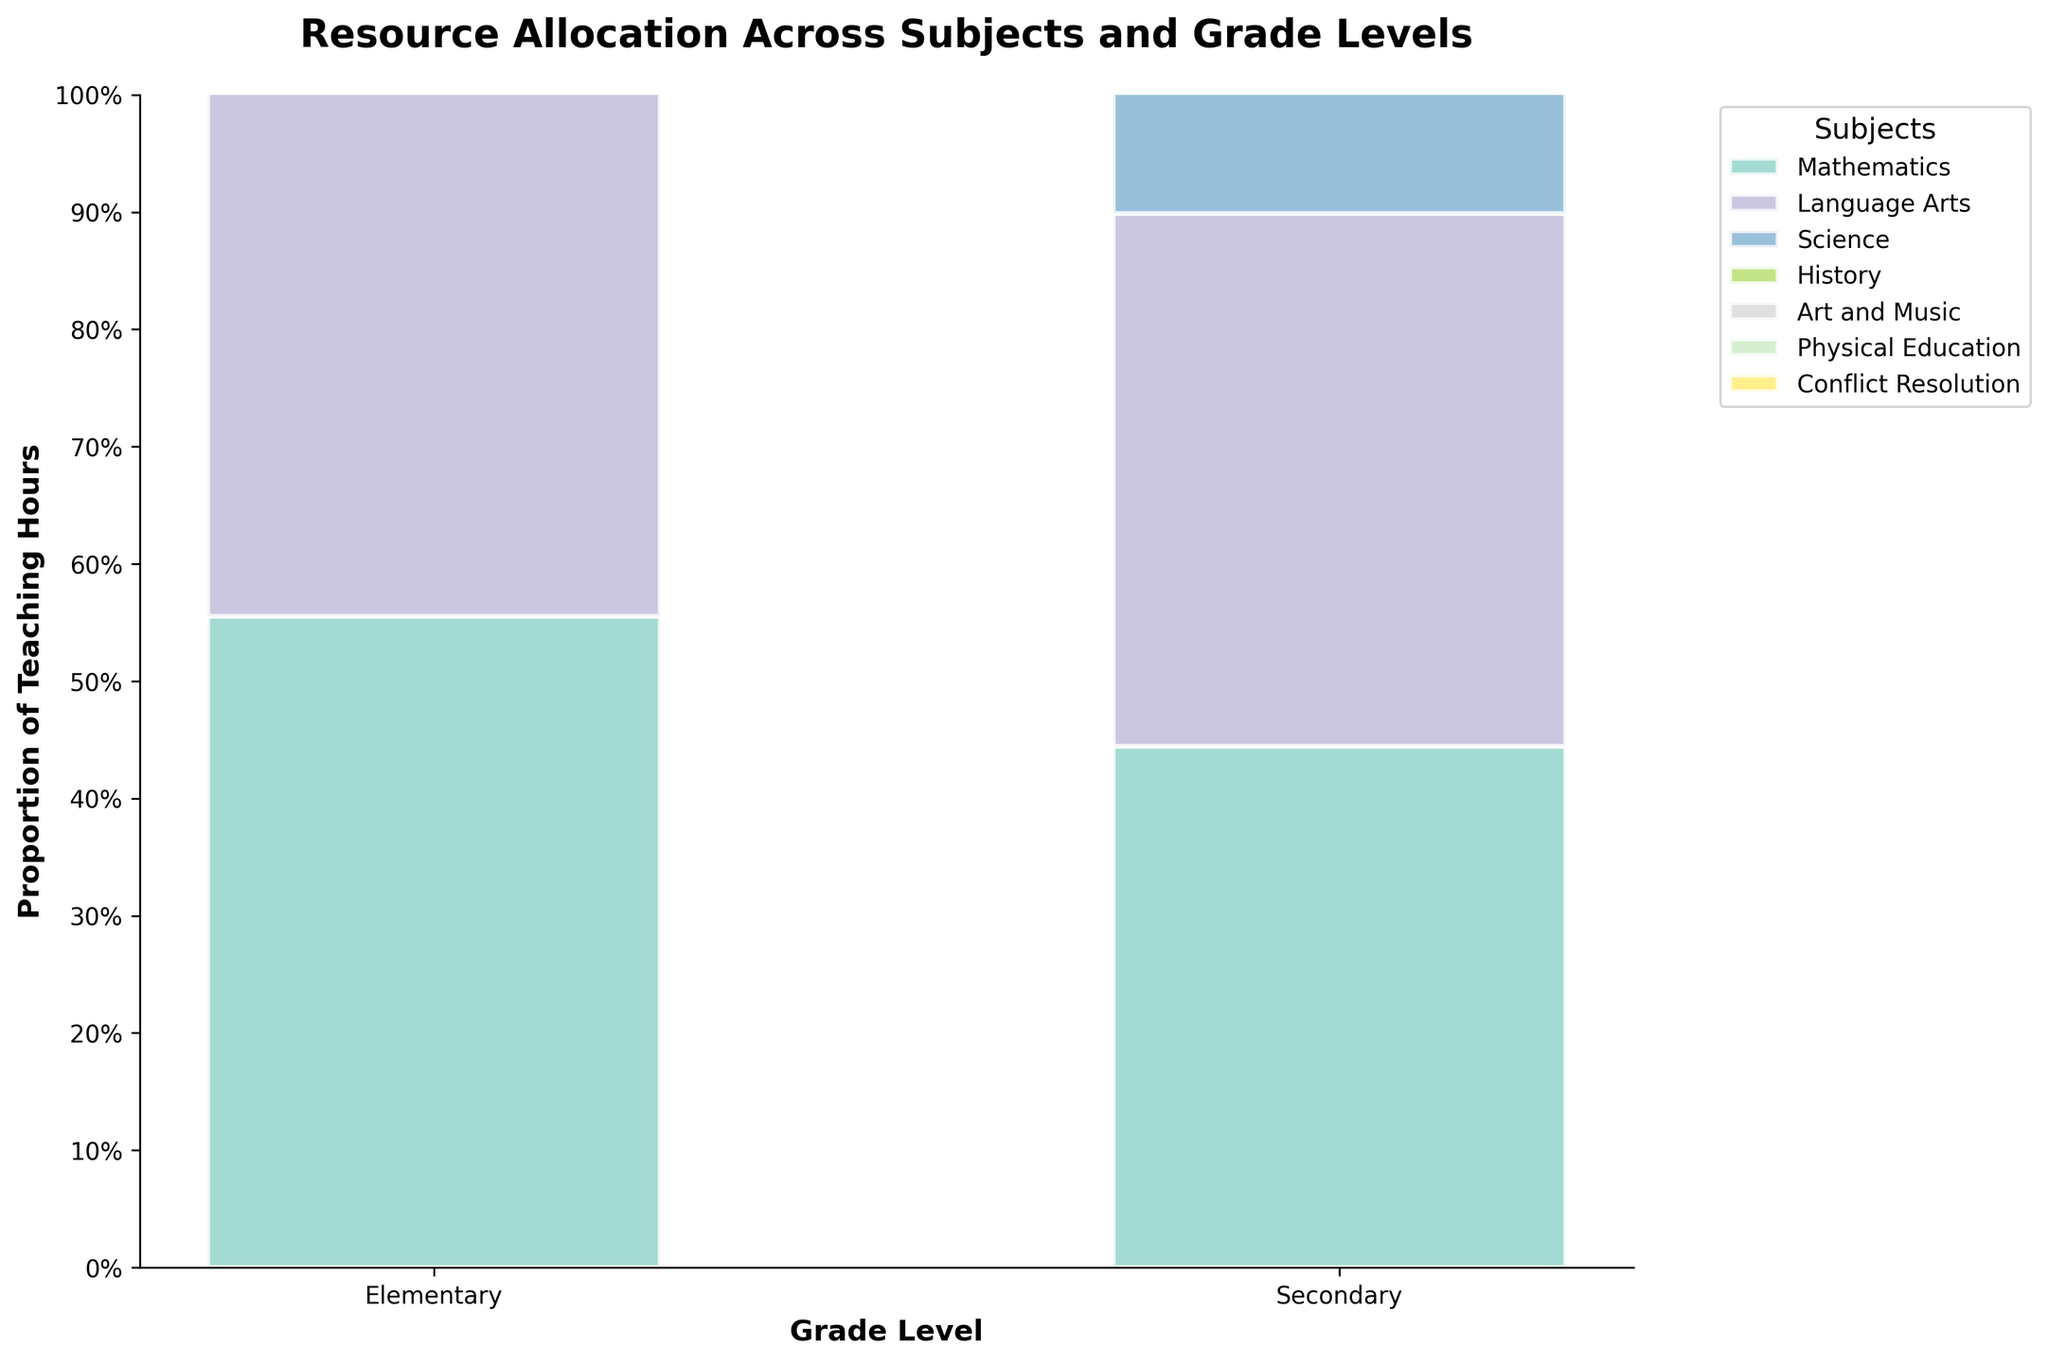Which subject has the highest proportion of teaching hours for Elementary grade levels? To find the subject with the highest proportion of teaching hours for Elementary grade levels, look at the tallest segment of the Elementary bar in the mosaic plot.
Answer: Language Arts How many subjects have more teaching hours allocated to Secondary grade levels than Elementary grade levels? Compare the height of each subject's bar segment between Elementary and Secondary grade levels. Count the subjects where the Secondary segment is taller.
Answer: Three subjects What is the total proportion of teaching hours allocated to Elementary for Science and Conflict Resolution combined? Add the height (proportion) of the Elementary segments for Science and Conflict Resolution from the mosaic plot.
Answer: 10% (Science) + 11% (Conflict Resolution) = 21% Which subject has the most balanced allocation of teaching hours between Elementary and Secondary grade levels? Identify the subject where the segments for Elementary and Secondary are closest in height.
Answer: History Are there any subjects that show a notable difference in allocation between Elementary and Secondary grade levels? If so, which ones? Look for subjects with a large disparity in segment heights between Elementary and Secondary grade levels.
Answer: Art and Music, Physical Education For the subject of Mathematics, which grade level has higher teaching hours allocated? Compare the height of the Mathematics segment for Elementary and Secondary in the mosaic plot to see which is taller.
Answer: Elementary Between Science and History, which subject has a greater proportion of teaching hours allocated to Secondary grade levels? Compare the heights of the segments for Secondary grade levels of Science and History.
Answer: Science What is the combined proportion of teaching hours for Art and Music and Physical Education for Secondary grade levels? Sum the proportions of teaching hours for Art and Music and Physical Education in the Secondary bar.
Answer: 5% Which two subjects have the smallest proportion of teaching hours allocated to Elementary grade levels? Identify the smallest segments for Elementary grade levels in the mosaic plot for two subjects.
Answer: Art and Music, Physical Education 